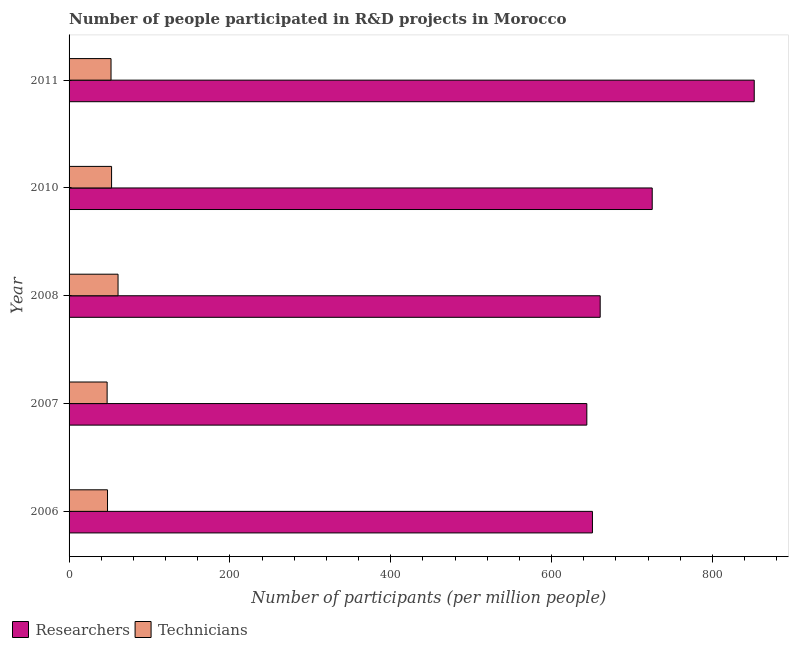How many different coloured bars are there?
Offer a terse response. 2. How many groups of bars are there?
Your answer should be compact. 5. What is the label of the 4th group of bars from the top?
Give a very brief answer. 2007. In how many cases, is the number of bars for a given year not equal to the number of legend labels?
Keep it short and to the point. 0. What is the number of technicians in 2007?
Your answer should be compact. 47.31. Across all years, what is the maximum number of researchers?
Ensure brevity in your answer.  851.9. Across all years, what is the minimum number of researchers?
Offer a terse response. 643.76. In which year was the number of researchers maximum?
Your answer should be compact. 2011. What is the total number of technicians in the graph?
Offer a terse response. 261.01. What is the difference between the number of researchers in 2006 and that in 2010?
Keep it short and to the point. -74.32. What is the difference between the number of technicians in 2010 and the number of researchers in 2008?
Give a very brief answer. -607.52. What is the average number of technicians per year?
Provide a succinct answer. 52.2. In the year 2006, what is the difference between the number of researchers and number of technicians?
Your response must be concise. 602.94. In how many years, is the number of technicians greater than 840 ?
Give a very brief answer. 0. What is the ratio of the number of researchers in 2007 to that in 2010?
Keep it short and to the point. 0.89. Is the difference between the number of technicians in 2007 and 2008 greater than the difference between the number of researchers in 2007 and 2008?
Your answer should be compact. Yes. What is the difference between the highest and the second highest number of technicians?
Provide a succinct answer. 8.04. What is the difference between the highest and the lowest number of researchers?
Your response must be concise. 208.14. In how many years, is the number of researchers greater than the average number of researchers taken over all years?
Offer a terse response. 2. Is the sum of the number of technicians in 2008 and 2010 greater than the maximum number of researchers across all years?
Your response must be concise. No. What does the 1st bar from the top in 2006 represents?
Provide a succinct answer. Technicians. What does the 2nd bar from the bottom in 2006 represents?
Make the answer very short. Technicians. How many years are there in the graph?
Your answer should be very brief. 5. Are the values on the major ticks of X-axis written in scientific E-notation?
Give a very brief answer. No. Does the graph contain grids?
Offer a very short reply. No. Where does the legend appear in the graph?
Offer a terse response. Bottom left. What is the title of the graph?
Your answer should be very brief. Number of people participated in R&D projects in Morocco. What is the label or title of the X-axis?
Offer a very short reply. Number of participants (per million people). What is the label or title of the Y-axis?
Give a very brief answer. Year. What is the Number of participants (per million people) in Researchers in 2006?
Offer a very short reply. 650.74. What is the Number of participants (per million people) of Technicians in 2006?
Keep it short and to the point. 47.8. What is the Number of participants (per million people) in Researchers in 2007?
Provide a succinct answer. 643.76. What is the Number of participants (per million people) in Technicians in 2007?
Your answer should be compact. 47.31. What is the Number of participants (per million people) in Researchers in 2008?
Your response must be concise. 660.37. What is the Number of participants (per million people) of Technicians in 2008?
Ensure brevity in your answer.  60.89. What is the Number of participants (per million people) of Researchers in 2010?
Your answer should be very brief. 725.06. What is the Number of participants (per million people) in Technicians in 2010?
Offer a very short reply. 52.85. What is the Number of participants (per million people) of Researchers in 2011?
Keep it short and to the point. 851.9. What is the Number of participants (per million people) in Technicians in 2011?
Provide a succinct answer. 52.16. Across all years, what is the maximum Number of participants (per million people) in Researchers?
Keep it short and to the point. 851.9. Across all years, what is the maximum Number of participants (per million people) of Technicians?
Make the answer very short. 60.89. Across all years, what is the minimum Number of participants (per million people) of Researchers?
Offer a terse response. 643.76. Across all years, what is the minimum Number of participants (per million people) of Technicians?
Offer a terse response. 47.31. What is the total Number of participants (per million people) in Researchers in the graph?
Provide a succinct answer. 3531.83. What is the total Number of participants (per million people) of Technicians in the graph?
Offer a very short reply. 261.01. What is the difference between the Number of participants (per million people) in Researchers in 2006 and that in 2007?
Ensure brevity in your answer.  6.97. What is the difference between the Number of participants (per million people) in Technicians in 2006 and that in 2007?
Offer a terse response. 0.49. What is the difference between the Number of participants (per million people) in Researchers in 2006 and that in 2008?
Your response must be concise. -9.64. What is the difference between the Number of participants (per million people) of Technicians in 2006 and that in 2008?
Your answer should be very brief. -13.09. What is the difference between the Number of participants (per million people) of Researchers in 2006 and that in 2010?
Make the answer very short. -74.32. What is the difference between the Number of participants (per million people) of Technicians in 2006 and that in 2010?
Keep it short and to the point. -5.05. What is the difference between the Number of participants (per million people) of Researchers in 2006 and that in 2011?
Make the answer very short. -201.17. What is the difference between the Number of participants (per million people) of Technicians in 2006 and that in 2011?
Provide a short and direct response. -4.37. What is the difference between the Number of participants (per million people) in Researchers in 2007 and that in 2008?
Your answer should be compact. -16.61. What is the difference between the Number of participants (per million people) of Technicians in 2007 and that in 2008?
Offer a very short reply. -13.59. What is the difference between the Number of participants (per million people) in Researchers in 2007 and that in 2010?
Your response must be concise. -81.29. What is the difference between the Number of participants (per million people) in Technicians in 2007 and that in 2010?
Offer a terse response. -5.55. What is the difference between the Number of participants (per million people) of Researchers in 2007 and that in 2011?
Keep it short and to the point. -208.14. What is the difference between the Number of participants (per million people) of Technicians in 2007 and that in 2011?
Ensure brevity in your answer.  -4.86. What is the difference between the Number of participants (per million people) in Researchers in 2008 and that in 2010?
Give a very brief answer. -64.69. What is the difference between the Number of participants (per million people) of Technicians in 2008 and that in 2010?
Ensure brevity in your answer.  8.04. What is the difference between the Number of participants (per million people) in Researchers in 2008 and that in 2011?
Your answer should be very brief. -191.53. What is the difference between the Number of participants (per million people) of Technicians in 2008 and that in 2011?
Give a very brief answer. 8.73. What is the difference between the Number of participants (per million people) in Researchers in 2010 and that in 2011?
Your answer should be compact. -126.84. What is the difference between the Number of participants (per million people) in Technicians in 2010 and that in 2011?
Ensure brevity in your answer.  0.69. What is the difference between the Number of participants (per million people) in Researchers in 2006 and the Number of participants (per million people) in Technicians in 2007?
Provide a short and direct response. 603.43. What is the difference between the Number of participants (per million people) of Researchers in 2006 and the Number of participants (per million people) of Technicians in 2008?
Keep it short and to the point. 589.84. What is the difference between the Number of participants (per million people) of Researchers in 2006 and the Number of participants (per million people) of Technicians in 2010?
Keep it short and to the point. 597.88. What is the difference between the Number of participants (per million people) of Researchers in 2006 and the Number of participants (per million people) of Technicians in 2011?
Give a very brief answer. 598.57. What is the difference between the Number of participants (per million people) in Researchers in 2007 and the Number of participants (per million people) in Technicians in 2008?
Ensure brevity in your answer.  582.87. What is the difference between the Number of participants (per million people) of Researchers in 2007 and the Number of participants (per million people) of Technicians in 2010?
Your answer should be compact. 590.91. What is the difference between the Number of participants (per million people) in Researchers in 2007 and the Number of participants (per million people) in Technicians in 2011?
Your answer should be compact. 591.6. What is the difference between the Number of participants (per million people) in Researchers in 2008 and the Number of participants (per million people) in Technicians in 2010?
Your answer should be very brief. 607.52. What is the difference between the Number of participants (per million people) of Researchers in 2008 and the Number of participants (per million people) of Technicians in 2011?
Offer a terse response. 608.21. What is the difference between the Number of participants (per million people) in Researchers in 2010 and the Number of participants (per million people) in Technicians in 2011?
Give a very brief answer. 672.89. What is the average Number of participants (per million people) of Researchers per year?
Offer a terse response. 706.37. What is the average Number of participants (per million people) of Technicians per year?
Give a very brief answer. 52.2. In the year 2006, what is the difference between the Number of participants (per million people) of Researchers and Number of participants (per million people) of Technicians?
Your answer should be very brief. 602.94. In the year 2007, what is the difference between the Number of participants (per million people) in Researchers and Number of participants (per million people) in Technicians?
Make the answer very short. 596.46. In the year 2008, what is the difference between the Number of participants (per million people) of Researchers and Number of participants (per million people) of Technicians?
Ensure brevity in your answer.  599.48. In the year 2010, what is the difference between the Number of participants (per million people) in Researchers and Number of participants (per million people) in Technicians?
Your response must be concise. 672.21. In the year 2011, what is the difference between the Number of participants (per million people) of Researchers and Number of participants (per million people) of Technicians?
Give a very brief answer. 799.74. What is the ratio of the Number of participants (per million people) in Researchers in 2006 to that in 2007?
Your answer should be very brief. 1.01. What is the ratio of the Number of participants (per million people) of Technicians in 2006 to that in 2007?
Keep it short and to the point. 1.01. What is the ratio of the Number of participants (per million people) of Researchers in 2006 to that in 2008?
Give a very brief answer. 0.99. What is the ratio of the Number of participants (per million people) of Technicians in 2006 to that in 2008?
Provide a short and direct response. 0.79. What is the ratio of the Number of participants (per million people) of Researchers in 2006 to that in 2010?
Ensure brevity in your answer.  0.9. What is the ratio of the Number of participants (per million people) in Technicians in 2006 to that in 2010?
Your response must be concise. 0.9. What is the ratio of the Number of participants (per million people) in Researchers in 2006 to that in 2011?
Offer a very short reply. 0.76. What is the ratio of the Number of participants (per million people) of Technicians in 2006 to that in 2011?
Provide a succinct answer. 0.92. What is the ratio of the Number of participants (per million people) in Researchers in 2007 to that in 2008?
Give a very brief answer. 0.97. What is the ratio of the Number of participants (per million people) in Technicians in 2007 to that in 2008?
Provide a short and direct response. 0.78. What is the ratio of the Number of participants (per million people) in Researchers in 2007 to that in 2010?
Your answer should be compact. 0.89. What is the ratio of the Number of participants (per million people) of Technicians in 2007 to that in 2010?
Ensure brevity in your answer.  0.9. What is the ratio of the Number of participants (per million people) of Researchers in 2007 to that in 2011?
Your answer should be compact. 0.76. What is the ratio of the Number of participants (per million people) of Technicians in 2007 to that in 2011?
Give a very brief answer. 0.91. What is the ratio of the Number of participants (per million people) in Researchers in 2008 to that in 2010?
Your response must be concise. 0.91. What is the ratio of the Number of participants (per million people) of Technicians in 2008 to that in 2010?
Provide a succinct answer. 1.15. What is the ratio of the Number of participants (per million people) of Researchers in 2008 to that in 2011?
Make the answer very short. 0.78. What is the ratio of the Number of participants (per million people) in Technicians in 2008 to that in 2011?
Your answer should be compact. 1.17. What is the ratio of the Number of participants (per million people) in Researchers in 2010 to that in 2011?
Give a very brief answer. 0.85. What is the ratio of the Number of participants (per million people) of Technicians in 2010 to that in 2011?
Your answer should be very brief. 1.01. What is the difference between the highest and the second highest Number of participants (per million people) in Researchers?
Offer a terse response. 126.84. What is the difference between the highest and the second highest Number of participants (per million people) of Technicians?
Make the answer very short. 8.04. What is the difference between the highest and the lowest Number of participants (per million people) in Researchers?
Provide a succinct answer. 208.14. What is the difference between the highest and the lowest Number of participants (per million people) of Technicians?
Offer a very short reply. 13.59. 